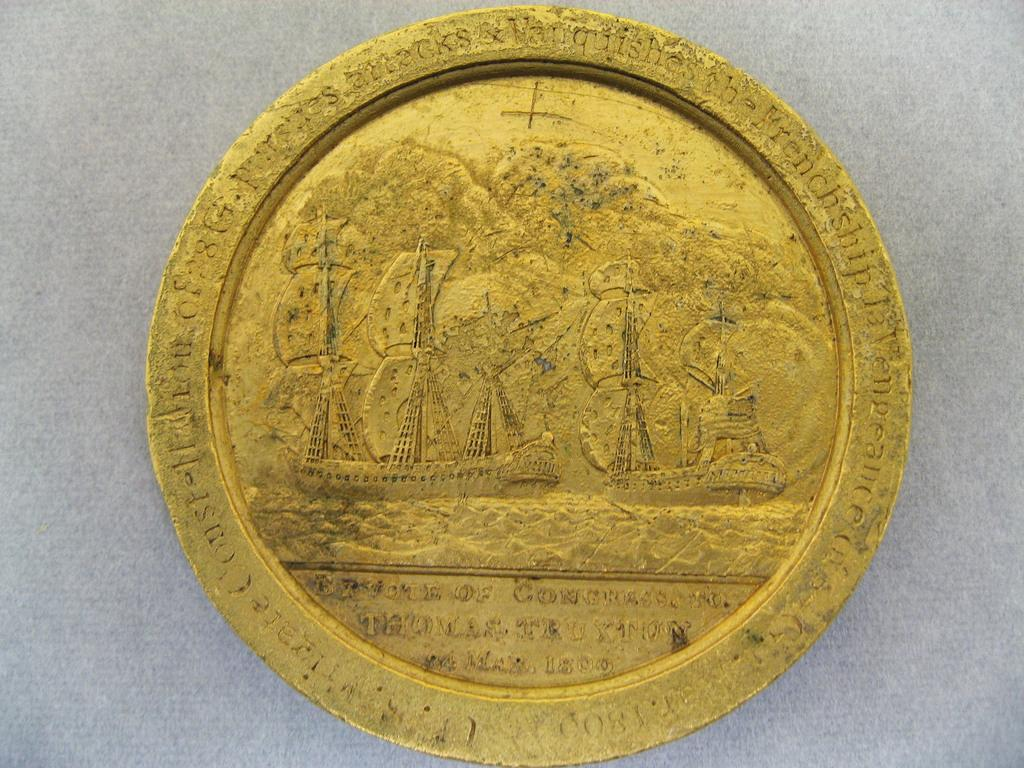What is the color of the object in the image? The object in the image is gold-colored. What is depicted on the object? The object has images of boats. Are there any words or letters on the object? Yes, there is text written on the object. What color is the background of the image? The background of the image is white. How does the grandmother feel about the pain and blood in the image? There is no mention of a grandmother, pain, or blood in the image; it features a gold-colored object with images of boats and text. 